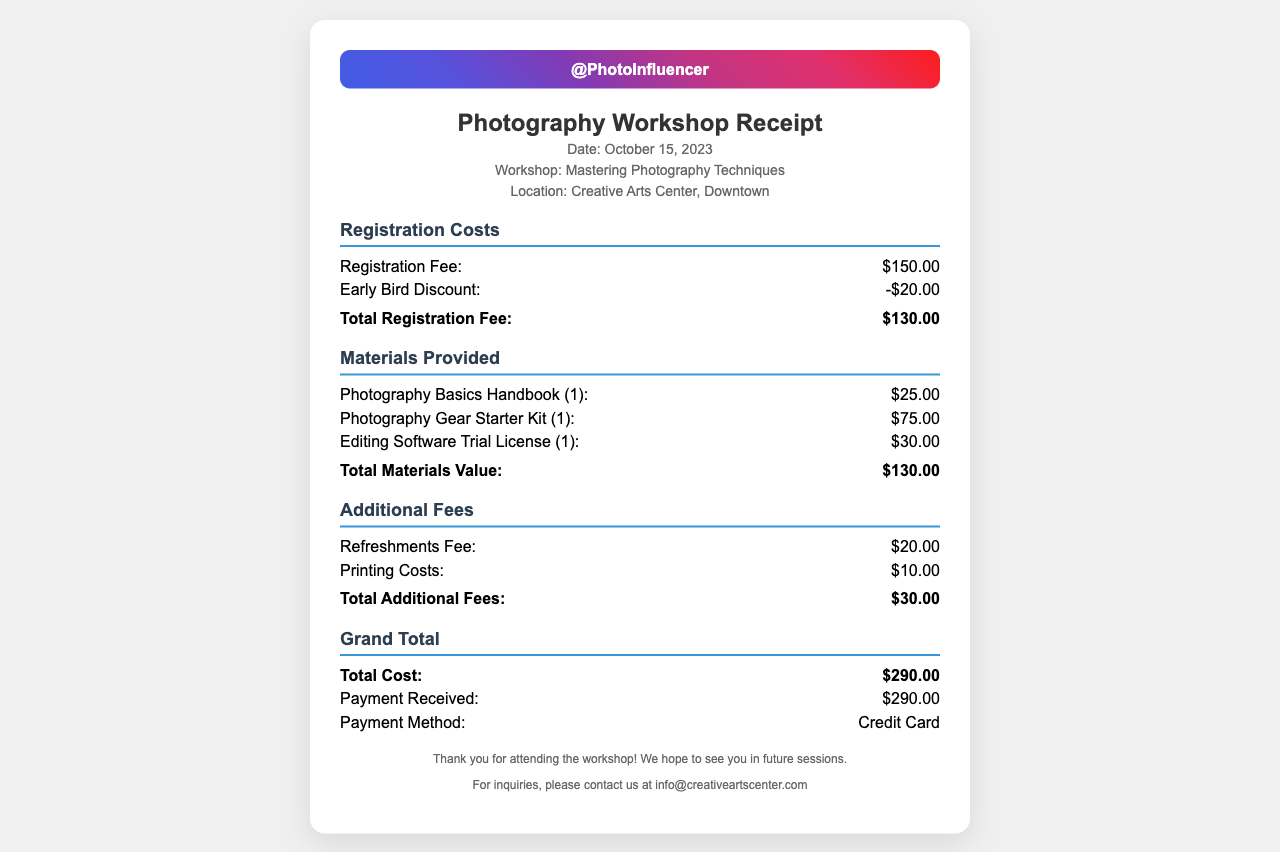What was the date of the workshop? The date of the workshop is explicitly mentioned in the header of the receipt.
Answer: October 15, 2023 What is the location of the workshop? The location is stated in the header section of the receipt.
Answer: Creative Arts Center, Downtown How much was the registration fee before discount? The registration fee before discount is listed under the registration costs section.
Answer: $150.00 What is the value of the photography basics handbook? The value of the photography basics handbook is specified under materials provided.
Answer: $25.00 How much was paid for refreshments? The refreshments fee is shown under additional fees.
Answer: $20.00 What is the total cost of the workshop? The total cost is presented in the grand total section of the receipt.
Answer: $290.00 What payment method was used? The payment method is indicated in the grand total section.
Answer: Credit Card What was the total value of materials provided? The total materials value is defined in the materials provided section.
Answer: $130.00 What discount was applied to the registration? The discount on the registration fee is mentioned as an item in the registration costs.
Answer: -$20.00 